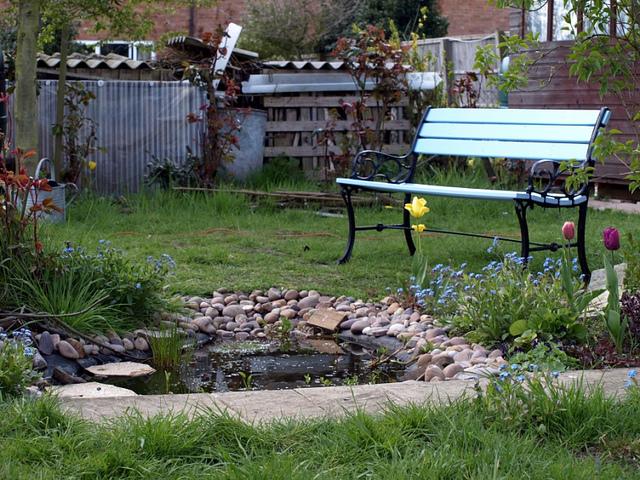What are the metal structures used for?
Quick response, please. Sitting. Is this a picturesque scene?
Answer briefly. Yes. What are the stones around?
Give a very brief answer. Pond. What are the roofs made of?
Keep it brief. Metal. What color is the bench?
Concise answer only. Blue. 